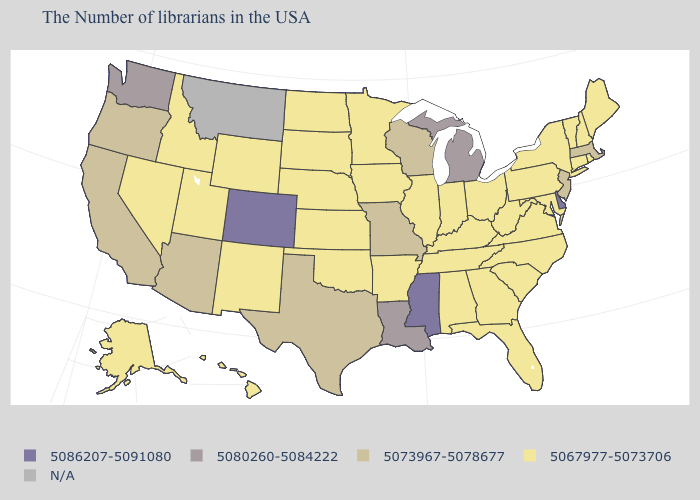What is the value of Idaho?
Quick response, please. 5067977-5073706. Name the states that have a value in the range N/A?
Concise answer only. Montana. Which states have the lowest value in the South?
Write a very short answer. Maryland, Virginia, North Carolina, South Carolina, West Virginia, Florida, Georgia, Kentucky, Alabama, Tennessee, Arkansas, Oklahoma. Which states have the lowest value in the USA?
Keep it brief. Maine, Rhode Island, New Hampshire, Vermont, Connecticut, New York, Maryland, Pennsylvania, Virginia, North Carolina, South Carolina, West Virginia, Ohio, Florida, Georgia, Kentucky, Indiana, Alabama, Tennessee, Illinois, Arkansas, Minnesota, Iowa, Kansas, Nebraska, Oklahoma, South Dakota, North Dakota, Wyoming, New Mexico, Utah, Idaho, Nevada, Alaska, Hawaii. What is the value of Louisiana?
Answer briefly. 5080260-5084222. What is the value of New Hampshire?
Be succinct. 5067977-5073706. Name the states that have a value in the range N/A?
Short answer required. Montana. What is the highest value in the South ?
Be succinct. 5086207-5091080. Among the states that border South Dakota , which have the lowest value?
Quick response, please. Minnesota, Iowa, Nebraska, North Dakota, Wyoming. Name the states that have a value in the range N/A?
Short answer required. Montana. What is the highest value in states that border Arizona?
Write a very short answer. 5086207-5091080. Name the states that have a value in the range 5067977-5073706?
Keep it brief. Maine, Rhode Island, New Hampshire, Vermont, Connecticut, New York, Maryland, Pennsylvania, Virginia, North Carolina, South Carolina, West Virginia, Ohio, Florida, Georgia, Kentucky, Indiana, Alabama, Tennessee, Illinois, Arkansas, Minnesota, Iowa, Kansas, Nebraska, Oklahoma, South Dakota, North Dakota, Wyoming, New Mexico, Utah, Idaho, Nevada, Alaska, Hawaii. What is the value of Connecticut?
Answer briefly. 5067977-5073706. Among the states that border Florida , which have the lowest value?
Answer briefly. Georgia, Alabama. 